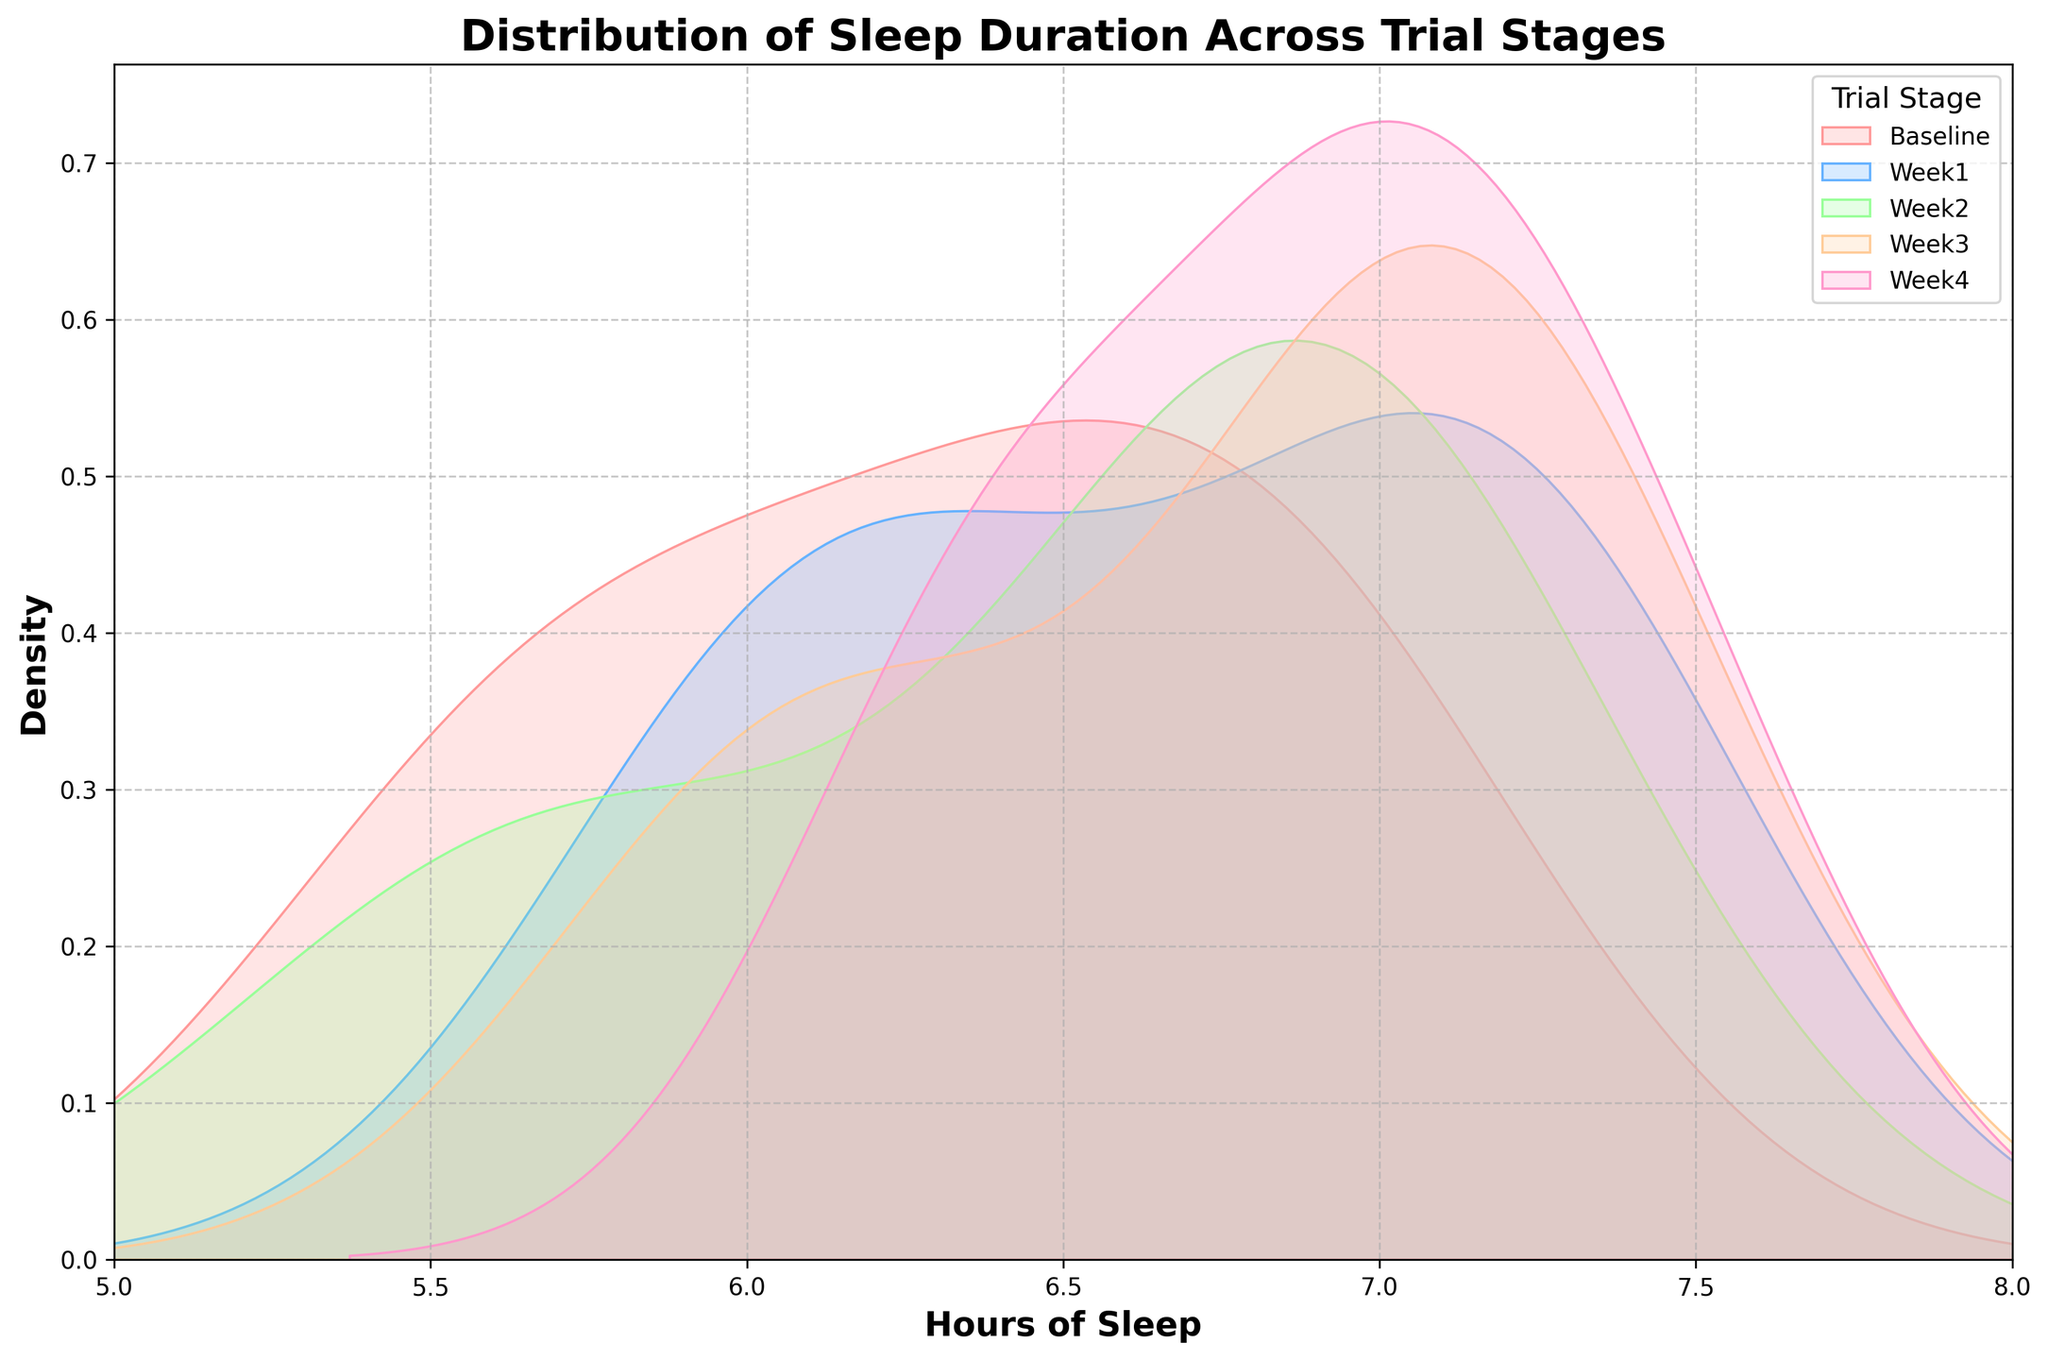What is the title of the figure? The title is located at the top center of the figure and summarizes the content.
Answer: Distribution of Sleep Duration Across Trial Stages How many stages of the drug trial are shown in the figure? By looking at the legend on the right side of the figure, we can count the number of stages listed.
Answer: Five Which stage has the widest spread of sleep duration? Observing the width of the density curves, the stage with the widest spread can be identified by its range.
Answer: Week1 In which stage do patients generally have the highest number of hours of sleep? The stage with the peak (highest density) shifted furthest to the right indicates the highest sleep duration.
Answer: Week4 Which stages have a density peak around 7 hours of sleep? Observing the figure, check which density curves peak or have a high point near the 7-hour mark on the x-axis.
Answer: Baseline, Week1, Week3, Week4 How does the sleep duration distribution change from Baseline to Week4? By comparing the density curves of Baseline and Week4, observe changes in peak position and spread.
Answer: The peak shifts to higher sleep hours and the distribution tightens Are there stages where sleep duration rarely falls below 6 hours? Identify stages whose density curves are minimal or nearly zero below the 6-hour mark on the x-axis.
Answer: Week3, Week4 Which stage appears to have the most consistent sleep duration among patients? The stage with the narrowest and highest peak indicates more consistent sleep duration among patients.
Answer: Week3 How does the density of Week2 compare to Week1 around 6 hours of sleep? Compare the heights of the density curves for Week2 and Week1 at the 6-hour mark.
Answer: Week2 has lower density than Week1 What is the approximate range of sleep hours with the highest density in Week1? Identify the range where the density curve for Week1 is at its highest (peak density) by looking at the x-axis values.
Answer: Approximately 6 to 7 hours 